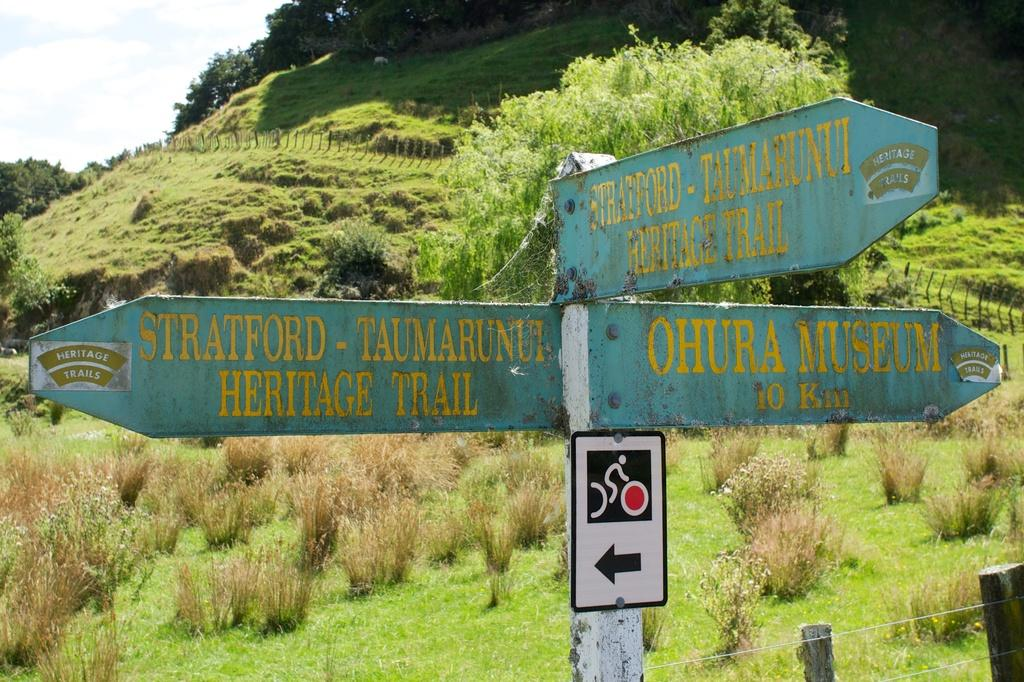<image>
Share a concise interpretation of the image provided. A road sign in a grassy area that points the directions to a museum, and two different trails. 